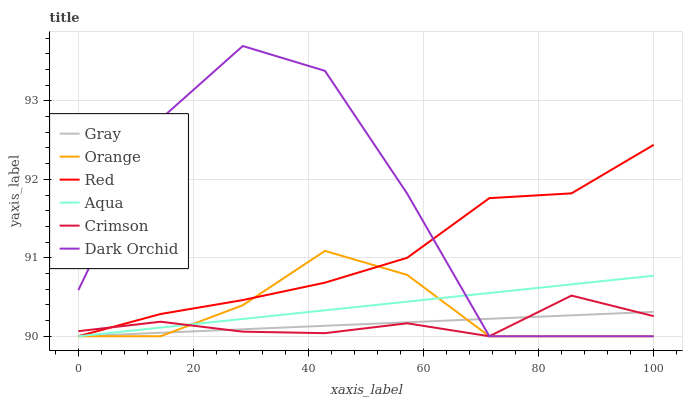Does Gray have the minimum area under the curve?
Answer yes or no. Yes. Does Dark Orchid have the maximum area under the curve?
Answer yes or no. Yes. Does Aqua have the minimum area under the curve?
Answer yes or no. No. Does Aqua have the maximum area under the curve?
Answer yes or no. No. Is Gray the smoothest?
Answer yes or no. Yes. Is Dark Orchid the roughest?
Answer yes or no. Yes. Is Aqua the smoothest?
Answer yes or no. No. Is Aqua the roughest?
Answer yes or no. No. Does Gray have the lowest value?
Answer yes or no. Yes. Does Dark Orchid have the highest value?
Answer yes or no. Yes. Does Aqua have the highest value?
Answer yes or no. No. Does Gray intersect Crimson?
Answer yes or no. Yes. Is Gray less than Crimson?
Answer yes or no. No. Is Gray greater than Crimson?
Answer yes or no. No. 